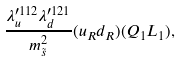<formula> <loc_0><loc_0><loc_500><loc_500>\frac { \lambda _ { u } ^ { \prime 1 1 2 } \lambda _ { d } ^ { \prime 1 2 1 } } { m ^ { 2 } _ { \tilde { s } } } ( u _ { R } d _ { R } ) ( Q _ { 1 } L _ { 1 } ) ,</formula> 